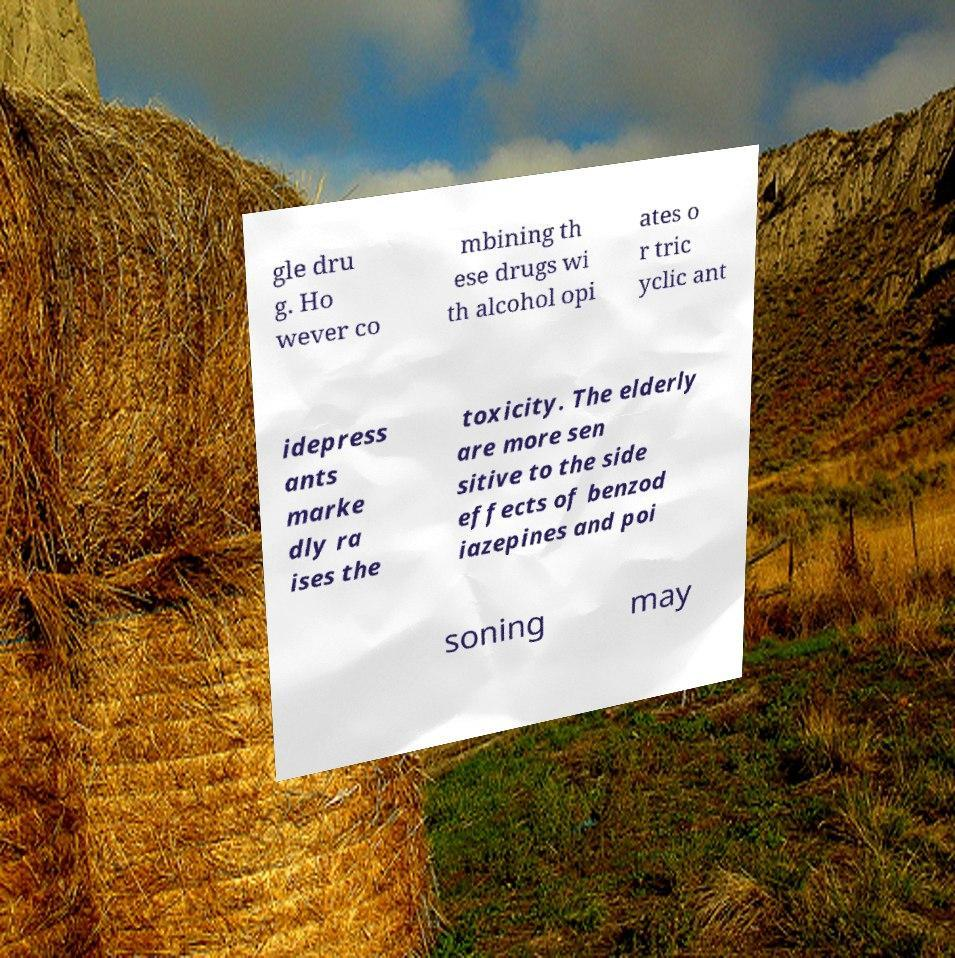Could you assist in decoding the text presented in this image and type it out clearly? gle dru g. Ho wever co mbining th ese drugs wi th alcohol opi ates o r tric yclic ant idepress ants marke dly ra ises the toxicity. The elderly are more sen sitive to the side effects of benzod iazepines and poi soning may 